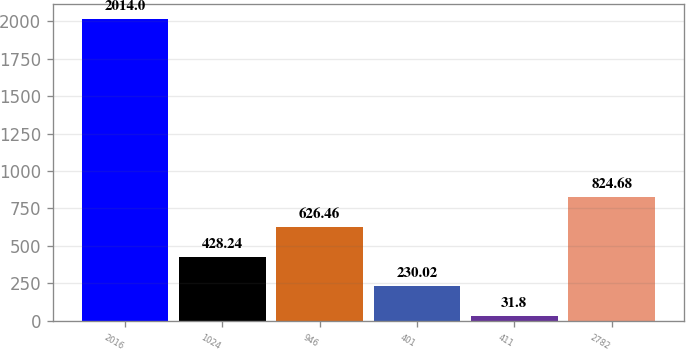<chart> <loc_0><loc_0><loc_500><loc_500><bar_chart><fcel>2016<fcel>1024<fcel>946<fcel>401<fcel>411<fcel>2782<nl><fcel>2014<fcel>428.24<fcel>626.46<fcel>230.02<fcel>31.8<fcel>824.68<nl></chart> 